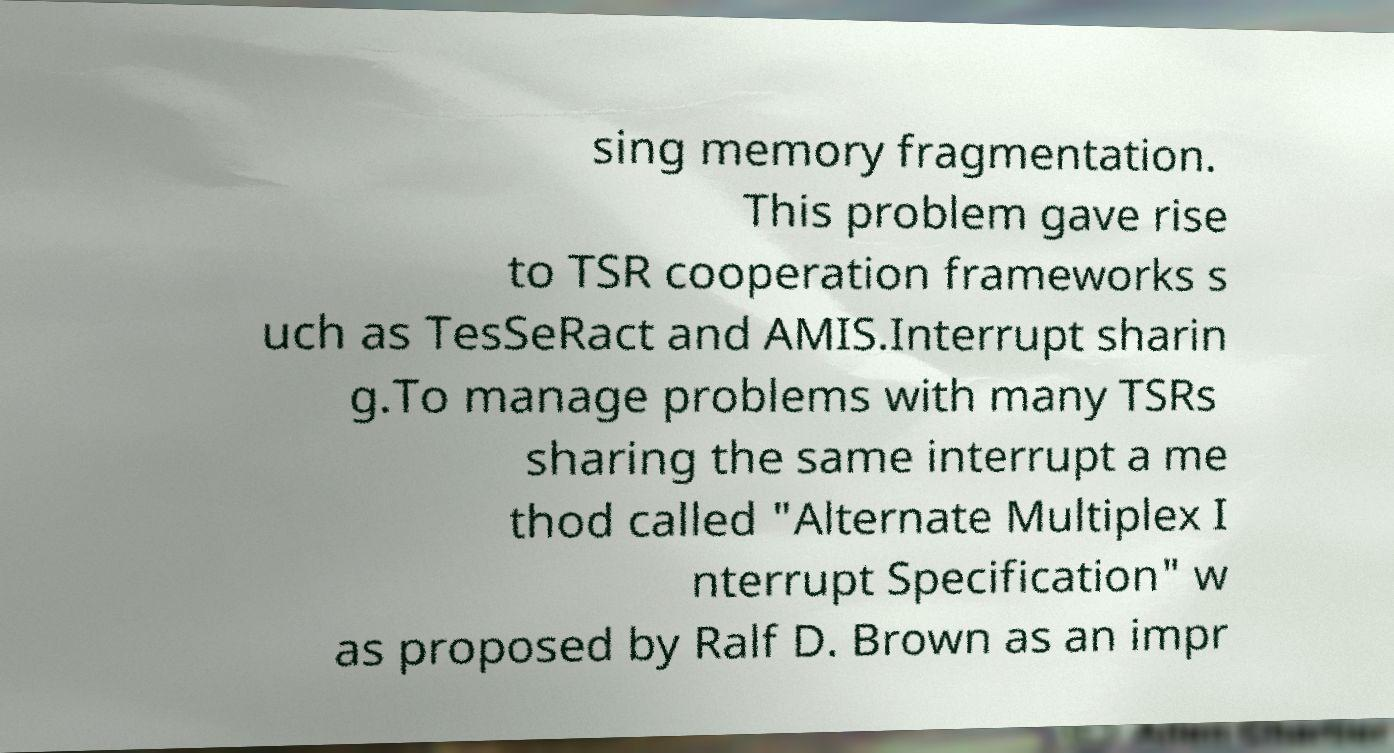Could you extract and type out the text from this image? sing memory fragmentation. This problem gave rise to TSR cooperation frameworks s uch as TesSeRact and AMIS.Interrupt sharin g.To manage problems with many TSRs sharing the same interrupt a me thod called "Alternate Multiplex I nterrupt Specification" w as proposed by Ralf D. Brown as an impr 